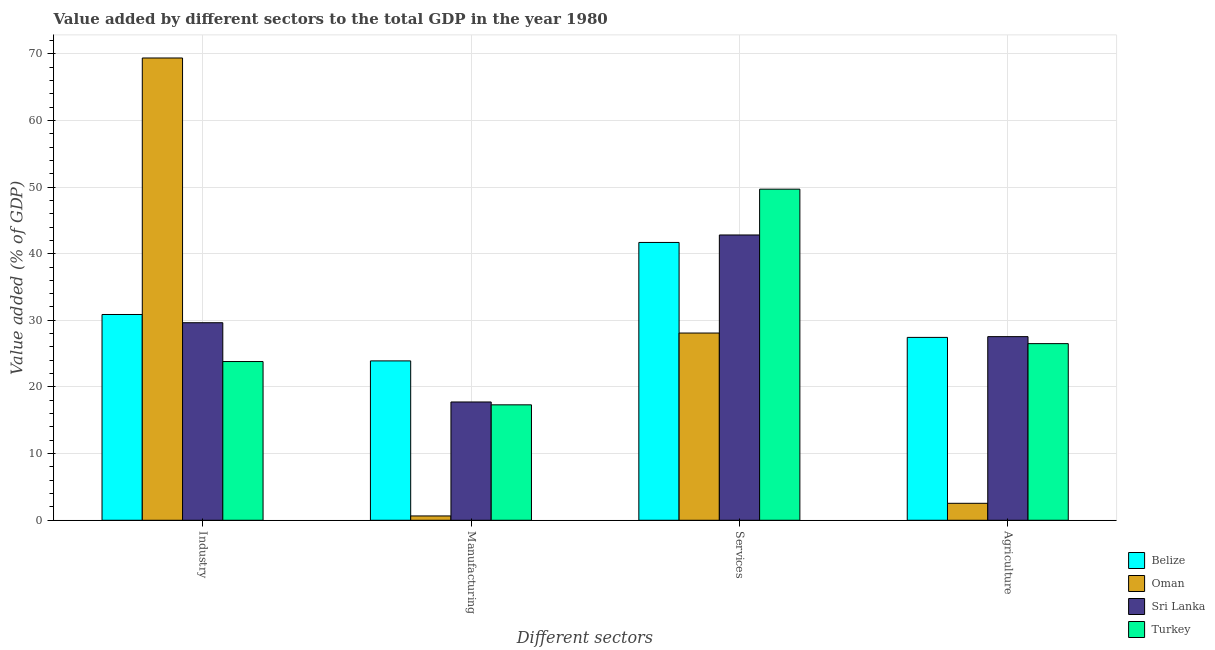How many groups of bars are there?
Your response must be concise. 4. Are the number of bars on each tick of the X-axis equal?
Your response must be concise. Yes. What is the label of the 4th group of bars from the left?
Offer a very short reply. Agriculture. What is the value added by industrial sector in Belize?
Make the answer very short. 30.88. Across all countries, what is the maximum value added by industrial sector?
Provide a succinct answer. 69.36. Across all countries, what is the minimum value added by agricultural sector?
Offer a very short reply. 2.55. In which country was the value added by industrial sector maximum?
Ensure brevity in your answer.  Oman. In which country was the value added by industrial sector minimum?
Make the answer very short. Turkey. What is the total value added by services sector in the graph?
Provide a succinct answer. 162.26. What is the difference between the value added by manufacturing sector in Belize and that in Turkey?
Offer a terse response. 6.59. What is the difference between the value added by services sector in Turkey and the value added by manufacturing sector in Sri Lanka?
Offer a terse response. 31.93. What is the average value added by industrial sector per country?
Offer a terse response. 38.42. What is the difference between the value added by industrial sector and value added by manufacturing sector in Oman?
Your answer should be very brief. 68.71. In how many countries, is the value added by services sector greater than 20 %?
Provide a succinct answer. 4. What is the ratio of the value added by manufacturing sector in Oman to that in Sri Lanka?
Your response must be concise. 0.04. What is the difference between the highest and the second highest value added by manufacturing sector?
Offer a very short reply. 6.16. What is the difference between the highest and the lowest value added by manufacturing sector?
Your answer should be compact. 23.26. Is it the case that in every country, the sum of the value added by industrial sector and value added by services sector is greater than the sum of value added by agricultural sector and value added by manufacturing sector?
Offer a terse response. No. What does the 1st bar from the left in Services represents?
Your response must be concise. Belize. What does the 2nd bar from the right in Industry represents?
Make the answer very short. Sri Lanka. Is it the case that in every country, the sum of the value added by industrial sector and value added by manufacturing sector is greater than the value added by services sector?
Offer a very short reply. No. How many bars are there?
Provide a short and direct response. 16. What is the difference between two consecutive major ticks on the Y-axis?
Ensure brevity in your answer.  10. Are the values on the major ticks of Y-axis written in scientific E-notation?
Give a very brief answer. No. Does the graph contain any zero values?
Ensure brevity in your answer.  No. How many legend labels are there?
Your response must be concise. 4. How are the legend labels stacked?
Your response must be concise. Vertical. What is the title of the graph?
Provide a short and direct response. Value added by different sectors to the total GDP in the year 1980. Does "Aruba" appear as one of the legend labels in the graph?
Keep it short and to the point. No. What is the label or title of the X-axis?
Your response must be concise. Different sectors. What is the label or title of the Y-axis?
Make the answer very short. Value added (% of GDP). What is the Value added (% of GDP) of Belize in Industry?
Provide a short and direct response. 30.88. What is the Value added (% of GDP) of Oman in Industry?
Offer a very short reply. 69.36. What is the Value added (% of GDP) of Sri Lanka in Industry?
Provide a short and direct response. 29.64. What is the Value added (% of GDP) in Turkey in Industry?
Ensure brevity in your answer.  23.82. What is the Value added (% of GDP) in Belize in Manufacturing?
Your answer should be compact. 23.91. What is the Value added (% of GDP) of Oman in Manufacturing?
Make the answer very short. 0.65. What is the Value added (% of GDP) in Sri Lanka in Manufacturing?
Your answer should be compact. 17.75. What is the Value added (% of GDP) in Turkey in Manufacturing?
Provide a short and direct response. 17.32. What is the Value added (% of GDP) of Belize in Services?
Ensure brevity in your answer.  41.69. What is the Value added (% of GDP) in Oman in Services?
Offer a terse response. 28.09. What is the Value added (% of GDP) of Sri Lanka in Services?
Keep it short and to the point. 42.81. What is the Value added (% of GDP) of Turkey in Services?
Your answer should be very brief. 49.68. What is the Value added (% of GDP) in Belize in Agriculture?
Offer a terse response. 27.44. What is the Value added (% of GDP) in Oman in Agriculture?
Keep it short and to the point. 2.55. What is the Value added (% of GDP) of Sri Lanka in Agriculture?
Keep it short and to the point. 27.55. What is the Value added (% of GDP) in Turkey in Agriculture?
Offer a terse response. 26.5. Across all Different sectors, what is the maximum Value added (% of GDP) of Belize?
Your answer should be compact. 41.69. Across all Different sectors, what is the maximum Value added (% of GDP) in Oman?
Ensure brevity in your answer.  69.36. Across all Different sectors, what is the maximum Value added (% of GDP) in Sri Lanka?
Ensure brevity in your answer.  42.81. Across all Different sectors, what is the maximum Value added (% of GDP) in Turkey?
Your response must be concise. 49.68. Across all Different sectors, what is the minimum Value added (% of GDP) in Belize?
Your answer should be very brief. 23.91. Across all Different sectors, what is the minimum Value added (% of GDP) in Oman?
Make the answer very short. 0.65. Across all Different sectors, what is the minimum Value added (% of GDP) in Sri Lanka?
Provide a succinct answer. 17.75. Across all Different sectors, what is the minimum Value added (% of GDP) of Turkey?
Offer a terse response. 17.32. What is the total Value added (% of GDP) of Belize in the graph?
Ensure brevity in your answer.  123.91. What is the total Value added (% of GDP) in Oman in the graph?
Your answer should be compact. 100.65. What is the total Value added (% of GDP) in Sri Lanka in the graph?
Give a very brief answer. 117.75. What is the total Value added (% of GDP) in Turkey in the graph?
Offer a very short reply. 117.32. What is the difference between the Value added (% of GDP) in Belize in Industry and that in Manufacturing?
Provide a succinct answer. 6.96. What is the difference between the Value added (% of GDP) of Oman in Industry and that in Manufacturing?
Offer a terse response. 68.71. What is the difference between the Value added (% of GDP) in Sri Lanka in Industry and that in Manufacturing?
Provide a succinct answer. 11.89. What is the difference between the Value added (% of GDP) in Turkey in Industry and that in Manufacturing?
Make the answer very short. 6.5. What is the difference between the Value added (% of GDP) of Belize in Industry and that in Services?
Provide a short and direct response. -10.81. What is the difference between the Value added (% of GDP) of Oman in Industry and that in Services?
Offer a terse response. 41.27. What is the difference between the Value added (% of GDP) of Sri Lanka in Industry and that in Services?
Offer a very short reply. -13.17. What is the difference between the Value added (% of GDP) in Turkey in Industry and that in Services?
Keep it short and to the point. -25.86. What is the difference between the Value added (% of GDP) in Belize in Industry and that in Agriculture?
Offer a very short reply. 3.44. What is the difference between the Value added (% of GDP) in Oman in Industry and that in Agriculture?
Ensure brevity in your answer.  66.82. What is the difference between the Value added (% of GDP) in Sri Lanka in Industry and that in Agriculture?
Keep it short and to the point. 2.09. What is the difference between the Value added (% of GDP) of Turkey in Industry and that in Agriculture?
Your response must be concise. -2.69. What is the difference between the Value added (% of GDP) of Belize in Manufacturing and that in Services?
Offer a very short reply. -17.77. What is the difference between the Value added (% of GDP) of Oman in Manufacturing and that in Services?
Make the answer very short. -27.44. What is the difference between the Value added (% of GDP) in Sri Lanka in Manufacturing and that in Services?
Provide a short and direct response. -25.06. What is the difference between the Value added (% of GDP) of Turkey in Manufacturing and that in Services?
Provide a succinct answer. -32.36. What is the difference between the Value added (% of GDP) of Belize in Manufacturing and that in Agriculture?
Your answer should be very brief. -3.53. What is the difference between the Value added (% of GDP) of Oman in Manufacturing and that in Agriculture?
Ensure brevity in your answer.  -1.9. What is the difference between the Value added (% of GDP) of Sri Lanka in Manufacturing and that in Agriculture?
Give a very brief answer. -9.8. What is the difference between the Value added (% of GDP) of Turkey in Manufacturing and that in Agriculture?
Ensure brevity in your answer.  -9.18. What is the difference between the Value added (% of GDP) of Belize in Services and that in Agriculture?
Keep it short and to the point. 14.25. What is the difference between the Value added (% of GDP) in Oman in Services and that in Agriculture?
Offer a terse response. 25.55. What is the difference between the Value added (% of GDP) in Sri Lanka in Services and that in Agriculture?
Make the answer very short. 15.25. What is the difference between the Value added (% of GDP) in Turkey in Services and that in Agriculture?
Keep it short and to the point. 23.18. What is the difference between the Value added (% of GDP) in Belize in Industry and the Value added (% of GDP) in Oman in Manufacturing?
Your answer should be compact. 30.23. What is the difference between the Value added (% of GDP) in Belize in Industry and the Value added (% of GDP) in Sri Lanka in Manufacturing?
Offer a terse response. 13.13. What is the difference between the Value added (% of GDP) of Belize in Industry and the Value added (% of GDP) of Turkey in Manufacturing?
Make the answer very short. 13.56. What is the difference between the Value added (% of GDP) in Oman in Industry and the Value added (% of GDP) in Sri Lanka in Manufacturing?
Make the answer very short. 51.61. What is the difference between the Value added (% of GDP) of Oman in Industry and the Value added (% of GDP) of Turkey in Manufacturing?
Your answer should be very brief. 52.04. What is the difference between the Value added (% of GDP) in Sri Lanka in Industry and the Value added (% of GDP) in Turkey in Manufacturing?
Keep it short and to the point. 12.32. What is the difference between the Value added (% of GDP) in Belize in Industry and the Value added (% of GDP) in Oman in Services?
Your response must be concise. 2.78. What is the difference between the Value added (% of GDP) in Belize in Industry and the Value added (% of GDP) in Sri Lanka in Services?
Offer a very short reply. -11.93. What is the difference between the Value added (% of GDP) in Belize in Industry and the Value added (% of GDP) in Turkey in Services?
Provide a short and direct response. -18.8. What is the difference between the Value added (% of GDP) of Oman in Industry and the Value added (% of GDP) of Sri Lanka in Services?
Make the answer very short. 26.56. What is the difference between the Value added (% of GDP) in Oman in Industry and the Value added (% of GDP) in Turkey in Services?
Provide a succinct answer. 19.68. What is the difference between the Value added (% of GDP) of Sri Lanka in Industry and the Value added (% of GDP) of Turkey in Services?
Your response must be concise. -20.04. What is the difference between the Value added (% of GDP) in Belize in Industry and the Value added (% of GDP) in Oman in Agriculture?
Your answer should be compact. 28.33. What is the difference between the Value added (% of GDP) of Belize in Industry and the Value added (% of GDP) of Sri Lanka in Agriculture?
Ensure brevity in your answer.  3.32. What is the difference between the Value added (% of GDP) of Belize in Industry and the Value added (% of GDP) of Turkey in Agriculture?
Make the answer very short. 4.37. What is the difference between the Value added (% of GDP) in Oman in Industry and the Value added (% of GDP) in Sri Lanka in Agriculture?
Offer a terse response. 41.81. What is the difference between the Value added (% of GDP) in Oman in Industry and the Value added (% of GDP) in Turkey in Agriculture?
Your answer should be compact. 42.86. What is the difference between the Value added (% of GDP) of Sri Lanka in Industry and the Value added (% of GDP) of Turkey in Agriculture?
Keep it short and to the point. 3.14. What is the difference between the Value added (% of GDP) in Belize in Manufacturing and the Value added (% of GDP) in Oman in Services?
Keep it short and to the point. -4.18. What is the difference between the Value added (% of GDP) of Belize in Manufacturing and the Value added (% of GDP) of Sri Lanka in Services?
Keep it short and to the point. -18.89. What is the difference between the Value added (% of GDP) in Belize in Manufacturing and the Value added (% of GDP) in Turkey in Services?
Provide a succinct answer. -25.77. What is the difference between the Value added (% of GDP) in Oman in Manufacturing and the Value added (% of GDP) in Sri Lanka in Services?
Your answer should be very brief. -42.16. What is the difference between the Value added (% of GDP) of Oman in Manufacturing and the Value added (% of GDP) of Turkey in Services?
Give a very brief answer. -49.03. What is the difference between the Value added (% of GDP) in Sri Lanka in Manufacturing and the Value added (% of GDP) in Turkey in Services?
Offer a terse response. -31.93. What is the difference between the Value added (% of GDP) of Belize in Manufacturing and the Value added (% of GDP) of Oman in Agriculture?
Ensure brevity in your answer.  21.37. What is the difference between the Value added (% of GDP) in Belize in Manufacturing and the Value added (% of GDP) in Sri Lanka in Agriculture?
Your answer should be compact. -3.64. What is the difference between the Value added (% of GDP) in Belize in Manufacturing and the Value added (% of GDP) in Turkey in Agriculture?
Provide a succinct answer. -2.59. What is the difference between the Value added (% of GDP) in Oman in Manufacturing and the Value added (% of GDP) in Sri Lanka in Agriculture?
Keep it short and to the point. -26.91. What is the difference between the Value added (% of GDP) in Oman in Manufacturing and the Value added (% of GDP) in Turkey in Agriculture?
Make the answer very short. -25.86. What is the difference between the Value added (% of GDP) of Sri Lanka in Manufacturing and the Value added (% of GDP) of Turkey in Agriculture?
Offer a terse response. -8.75. What is the difference between the Value added (% of GDP) of Belize in Services and the Value added (% of GDP) of Oman in Agriculture?
Provide a short and direct response. 39.14. What is the difference between the Value added (% of GDP) of Belize in Services and the Value added (% of GDP) of Sri Lanka in Agriculture?
Keep it short and to the point. 14.13. What is the difference between the Value added (% of GDP) in Belize in Services and the Value added (% of GDP) in Turkey in Agriculture?
Keep it short and to the point. 15.18. What is the difference between the Value added (% of GDP) of Oman in Services and the Value added (% of GDP) of Sri Lanka in Agriculture?
Offer a very short reply. 0.54. What is the difference between the Value added (% of GDP) in Oman in Services and the Value added (% of GDP) in Turkey in Agriculture?
Your answer should be compact. 1.59. What is the difference between the Value added (% of GDP) in Sri Lanka in Services and the Value added (% of GDP) in Turkey in Agriculture?
Keep it short and to the point. 16.3. What is the average Value added (% of GDP) of Belize per Different sectors?
Your answer should be compact. 30.98. What is the average Value added (% of GDP) in Oman per Different sectors?
Provide a succinct answer. 25.16. What is the average Value added (% of GDP) of Sri Lanka per Different sectors?
Ensure brevity in your answer.  29.44. What is the average Value added (% of GDP) in Turkey per Different sectors?
Your answer should be compact. 29.33. What is the difference between the Value added (% of GDP) in Belize and Value added (% of GDP) in Oman in Industry?
Offer a very short reply. -38.49. What is the difference between the Value added (% of GDP) in Belize and Value added (% of GDP) in Sri Lanka in Industry?
Your answer should be compact. 1.24. What is the difference between the Value added (% of GDP) in Belize and Value added (% of GDP) in Turkey in Industry?
Provide a succinct answer. 7.06. What is the difference between the Value added (% of GDP) of Oman and Value added (% of GDP) of Sri Lanka in Industry?
Provide a succinct answer. 39.72. What is the difference between the Value added (% of GDP) in Oman and Value added (% of GDP) in Turkey in Industry?
Make the answer very short. 45.55. What is the difference between the Value added (% of GDP) in Sri Lanka and Value added (% of GDP) in Turkey in Industry?
Your response must be concise. 5.82. What is the difference between the Value added (% of GDP) in Belize and Value added (% of GDP) in Oman in Manufacturing?
Offer a very short reply. 23.26. What is the difference between the Value added (% of GDP) in Belize and Value added (% of GDP) in Sri Lanka in Manufacturing?
Offer a very short reply. 6.16. What is the difference between the Value added (% of GDP) of Belize and Value added (% of GDP) of Turkey in Manufacturing?
Provide a succinct answer. 6.59. What is the difference between the Value added (% of GDP) in Oman and Value added (% of GDP) in Sri Lanka in Manufacturing?
Ensure brevity in your answer.  -17.1. What is the difference between the Value added (% of GDP) in Oman and Value added (% of GDP) in Turkey in Manufacturing?
Your answer should be very brief. -16.67. What is the difference between the Value added (% of GDP) in Sri Lanka and Value added (% of GDP) in Turkey in Manufacturing?
Your answer should be compact. 0.43. What is the difference between the Value added (% of GDP) in Belize and Value added (% of GDP) in Oman in Services?
Your answer should be compact. 13.59. What is the difference between the Value added (% of GDP) in Belize and Value added (% of GDP) in Sri Lanka in Services?
Give a very brief answer. -1.12. What is the difference between the Value added (% of GDP) in Belize and Value added (% of GDP) in Turkey in Services?
Provide a succinct answer. -7.99. What is the difference between the Value added (% of GDP) in Oman and Value added (% of GDP) in Sri Lanka in Services?
Give a very brief answer. -14.71. What is the difference between the Value added (% of GDP) in Oman and Value added (% of GDP) in Turkey in Services?
Provide a succinct answer. -21.59. What is the difference between the Value added (% of GDP) of Sri Lanka and Value added (% of GDP) of Turkey in Services?
Make the answer very short. -6.87. What is the difference between the Value added (% of GDP) in Belize and Value added (% of GDP) in Oman in Agriculture?
Ensure brevity in your answer.  24.89. What is the difference between the Value added (% of GDP) of Belize and Value added (% of GDP) of Sri Lanka in Agriculture?
Your answer should be compact. -0.12. What is the difference between the Value added (% of GDP) in Belize and Value added (% of GDP) in Turkey in Agriculture?
Offer a terse response. 0.93. What is the difference between the Value added (% of GDP) in Oman and Value added (% of GDP) in Sri Lanka in Agriculture?
Give a very brief answer. -25.01. What is the difference between the Value added (% of GDP) of Oman and Value added (% of GDP) of Turkey in Agriculture?
Give a very brief answer. -23.96. What is the difference between the Value added (% of GDP) in Sri Lanka and Value added (% of GDP) in Turkey in Agriculture?
Provide a succinct answer. 1.05. What is the ratio of the Value added (% of GDP) in Belize in Industry to that in Manufacturing?
Your response must be concise. 1.29. What is the ratio of the Value added (% of GDP) of Oman in Industry to that in Manufacturing?
Your answer should be compact. 106.95. What is the ratio of the Value added (% of GDP) of Sri Lanka in Industry to that in Manufacturing?
Your answer should be compact. 1.67. What is the ratio of the Value added (% of GDP) in Turkey in Industry to that in Manufacturing?
Provide a short and direct response. 1.38. What is the ratio of the Value added (% of GDP) in Belize in Industry to that in Services?
Your answer should be very brief. 0.74. What is the ratio of the Value added (% of GDP) of Oman in Industry to that in Services?
Keep it short and to the point. 2.47. What is the ratio of the Value added (% of GDP) of Sri Lanka in Industry to that in Services?
Your answer should be compact. 0.69. What is the ratio of the Value added (% of GDP) in Turkey in Industry to that in Services?
Your answer should be very brief. 0.48. What is the ratio of the Value added (% of GDP) in Belize in Industry to that in Agriculture?
Offer a terse response. 1.13. What is the ratio of the Value added (% of GDP) of Oman in Industry to that in Agriculture?
Your answer should be compact. 27.25. What is the ratio of the Value added (% of GDP) in Sri Lanka in Industry to that in Agriculture?
Provide a succinct answer. 1.08. What is the ratio of the Value added (% of GDP) in Turkey in Industry to that in Agriculture?
Provide a short and direct response. 0.9. What is the ratio of the Value added (% of GDP) of Belize in Manufacturing to that in Services?
Offer a very short reply. 0.57. What is the ratio of the Value added (% of GDP) of Oman in Manufacturing to that in Services?
Your response must be concise. 0.02. What is the ratio of the Value added (% of GDP) of Sri Lanka in Manufacturing to that in Services?
Offer a very short reply. 0.41. What is the ratio of the Value added (% of GDP) in Turkey in Manufacturing to that in Services?
Ensure brevity in your answer.  0.35. What is the ratio of the Value added (% of GDP) of Belize in Manufacturing to that in Agriculture?
Your response must be concise. 0.87. What is the ratio of the Value added (% of GDP) of Oman in Manufacturing to that in Agriculture?
Your answer should be compact. 0.25. What is the ratio of the Value added (% of GDP) of Sri Lanka in Manufacturing to that in Agriculture?
Your answer should be compact. 0.64. What is the ratio of the Value added (% of GDP) of Turkey in Manufacturing to that in Agriculture?
Offer a very short reply. 0.65. What is the ratio of the Value added (% of GDP) in Belize in Services to that in Agriculture?
Provide a succinct answer. 1.52. What is the ratio of the Value added (% of GDP) in Oman in Services to that in Agriculture?
Your answer should be compact. 11.03. What is the ratio of the Value added (% of GDP) in Sri Lanka in Services to that in Agriculture?
Offer a very short reply. 1.55. What is the ratio of the Value added (% of GDP) in Turkey in Services to that in Agriculture?
Your answer should be compact. 1.87. What is the difference between the highest and the second highest Value added (% of GDP) of Belize?
Provide a succinct answer. 10.81. What is the difference between the highest and the second highest Value added (% of GDP) of Oman?
Make the answer very short. 41.27. What is the difference between the highest and the second highest Value added (% of GDP) of Sri Lanka?
Your answer should be compact. 13.17. What is the difference between the highest and the second highest Value added (% of GDP) in Turkey?
Provide a succinct answer. 23.18. What is the difference between the highest and the lowest Value added (% of GDP) of Belize?
Your answer should be compact. 17.77. What is the difference between the highest and the lowest Value added (% of GDP) of Oman?
Your answer should be very brief. 68.71. What is the difference between the highest and the lowest Value added (% of GDP) in Sri Lanka?
Your response must be concise. 25.06. What is the difference between the highest and the lowest Value added (% of GDP) in Turkey?
Your answer should be compact. 32.36. 